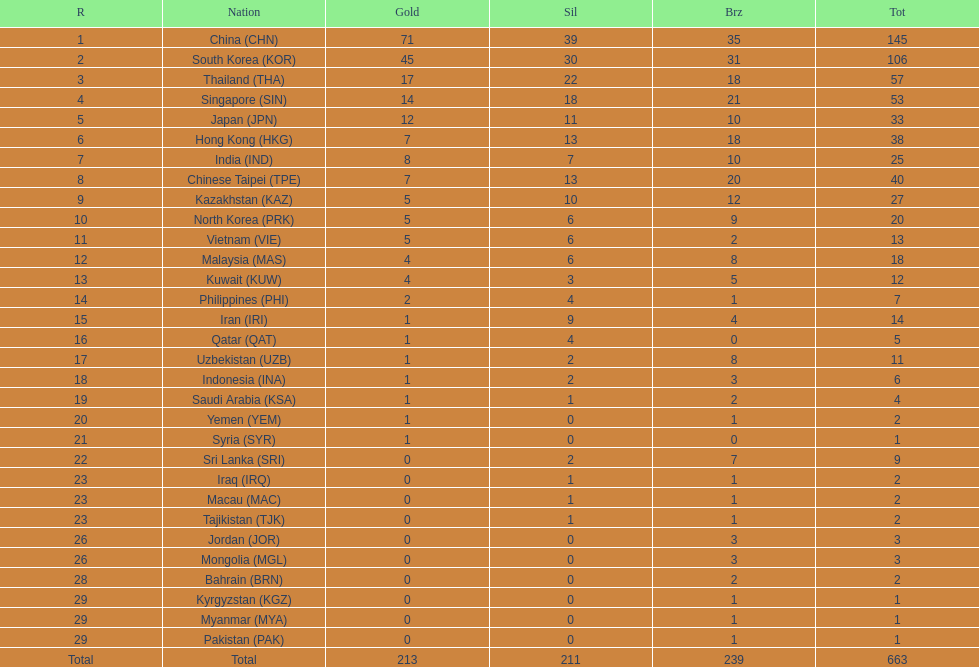What were the number of medals iran earned? 14. I'm looking to parse the entire table for insights. Could you assist me with that? {'header': ['R', 'Nation', 'Gold', 'Sil', 'Brz', 'Tot'], 'rows': [['1', 'China\xa0(CHN)', '71', '39', '35', '145'], ['2', 'South Korea\xa0(KOR)', '45', '30', '31', '106'], ['3', 'Thailand\xa0(THA)', '17', '22', '18', '57'], ['4', 'Singapore\xa0(SIN)', '14', '18', '21', '53'], ['5', 'Japan\xa0(JPN)', '12', '11', '10', '33'], ['6', 'Hong Kong\xa0(HKG)', '7', '13', '18', '38'], ['7', 'India\xa0(IND)', '8', '7', '10', '25'], ['8', 'Chinese Taipei\xa0(TPE)', '7', '13', '20', '40'], ['9', 'Kazakhstan\xa0(KAZ)', '5', '10', '12', '27'], ['10', 'North Korea\xa0(PRK)', '5', '6', '9', '20'], ['11', 'Vietnam\xa0(VIE)', '5', '6', '2', '13'], ['12', 'Malaysia\xa0(MAS)', '4', '6', '8', '18'], ['13', 'Kuwait\xa0(KUW)', '4', '3', '5', '12'], ['14', 'Philippines\xa0(PHI)', '2', '4', '1', '7'], ['15', 'Iran\xa0(IRI)', '1', '9', '4', '14'], ['16', 'Qatar\xa0(QAT)', '1', '4', '0', '5'], ['17', 'Uzbekistan\xa0(UZB)', '1', '2', '8', '11'], ['18', 'Indonesia\xa0(INA)', '1', '2', '3', '6'], ['19', 'Saudi Arabia\xa0(KSA)', '1', '1', '2', '4'], ['20', 'Yemen\xa0(YEM)', '1', '0', '1', '2'], ['21', 'Syria\xa0(SYR)', '1', '0', '0', '1'], ['22', 'Sri Lanka\xa0(SRI)', '0', '2', '7', '9'], ['23', 'Iraq\xa0(IRQ)', '0', '1', '1', '2'], ['23', 'Macau\xa0(MAC)', '0', '1', '1', '2'], ['23', 'Tajikistan\xa0(TJK)', '0', '1', '1', '2'], ['26', 'Jordan\xa0(JOR)', '0', '0', '3', '3'], ['26', 'Mongolia\xa0(MGL)', '0', '0', '3', '3'], ['28', 'Bahrain\xa0(BRN)', '0', '0', '2', '2'], ['29', 'Kyrgyzstan\xa0(KGZ)', '0', '0', '1', '1'], ['29', 'Myanmar\xa0(MYA)', '0', '0', '1', '1'], ['29', 'Pakistan\xa0(PAK)', '0', '0', '1', '1'], ['Total', 'Total', '213', '211', '239', '663']]} 